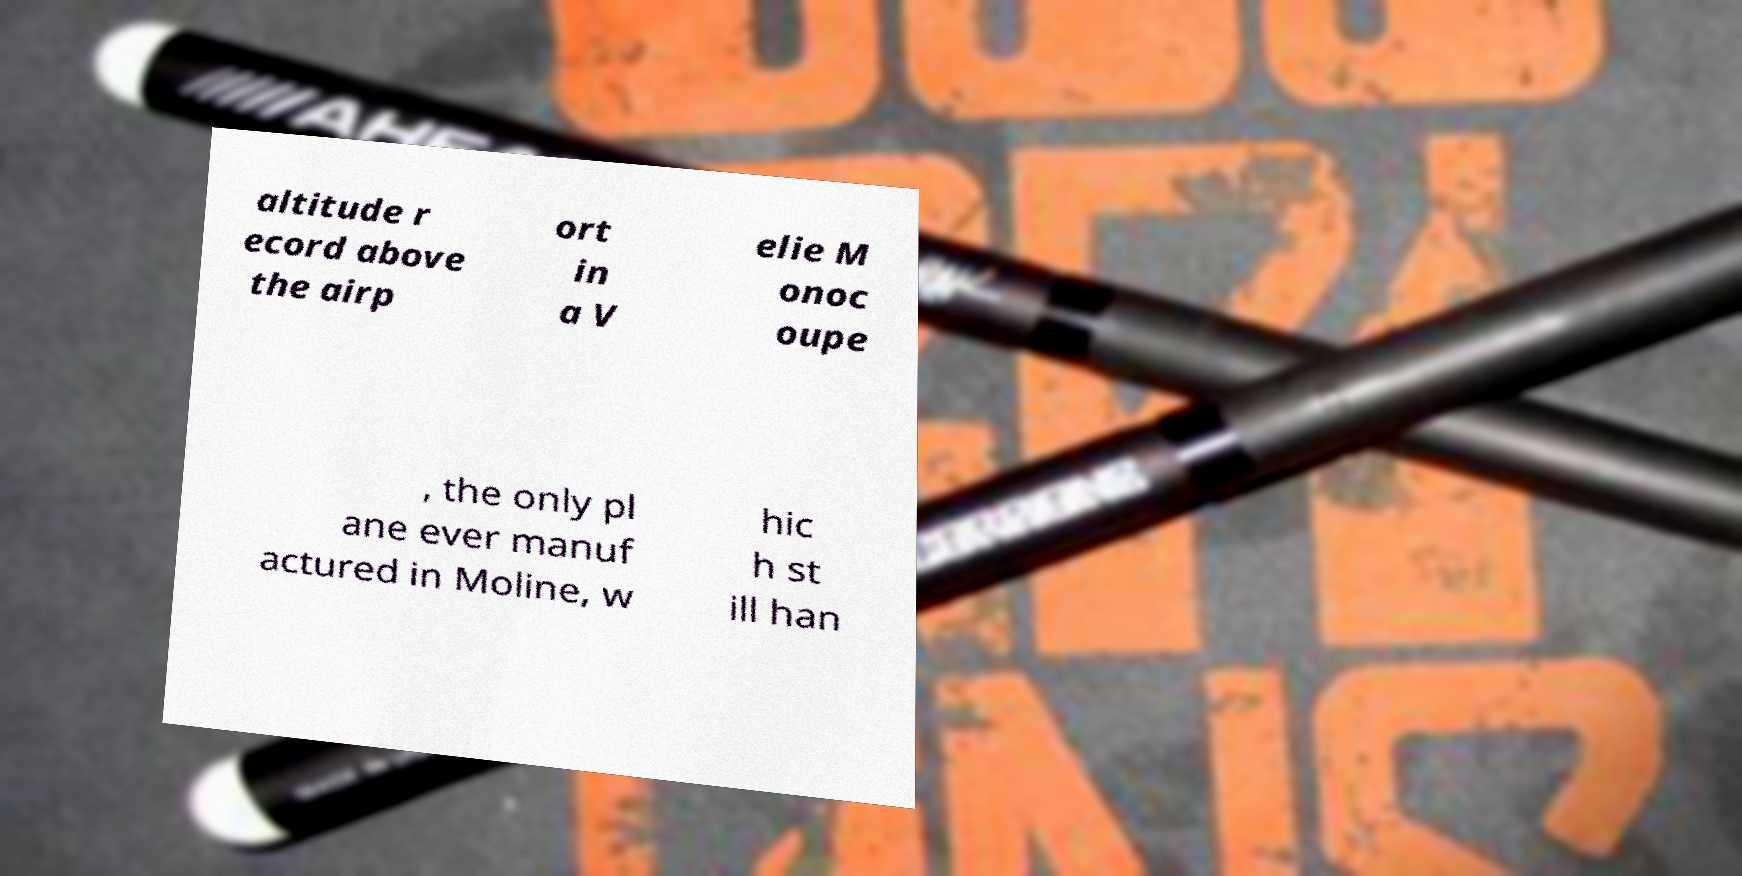Can you read and provide the text displayed in the image?This photo seems to have some interesting text. Can you extract and type it out for me? altitude r ecord above the airp ort in a V elie M onoc oupe , the only pl ane ever manuf actured in Moline, w hic h st ill han 